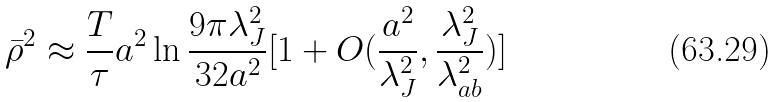<formula> <loc_0><loc_0><loc_500><loc_500>\bar { \rho } ^ { 2 } \approx \frac { T } { \tau } a ^ { 2 } \ln \frac { 9 \pi \lambda _ { J } ^ { 2 } } { 3 2 a ^ { 2 } } [ 1 + O ( \frac { a ^ { 2 } } { \lambda _ { J } ^ { 2 } } , \frac { \lambda _ { J } ^ { 2 } } { \lambda _ { a b } ^ { 2 } } ) ]</formula> 